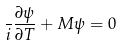Convert formula to latex. <formula><loc_0><loc_0><loc_500><loc_500>\frac { } { i } \frac { \partial \psi } { \partial T } + M \psi = 0</formula> 